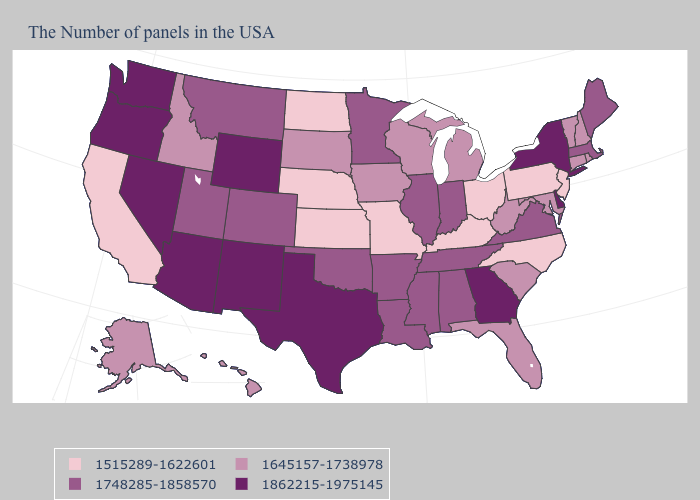Does South Carolina have the lowest value in the USA?
Concise answer only. No. Does Oregon have the highest value in the West?
Quick response, please. Yes. Which states have the lowest value in the Northeast?
Be succinct. New Jersey, Pennsylvania. What is the highest value in the USA?
Be succinct. 1862215-1975145. Does Utah have the lowest value in the USA?
Write a very short answer. No. Name the states that have a value in the range 1862215-1975145?
Be succinct. New York, Delaware, Georgia, Texas, Wyoming, New Mexico, Arizona, Nevada, Washington, Oregon. What is the value of Delaware?
Write a very short answer. 1862215-1975145. Among the states that border Montana , which have the highest value?
Write a very short answer. Wyoming. Among the states that border Pennsylvania , does Maryland have the lowest value?
Answer briefly. No. Name the states that have a value in the range 1515289-1622601?
Keep it brief. New Jersey, Pennsylvania, North Carolina, Ohio, Kentucky, Missouri, Kansas, Nebraska, North Dakota, California. Name the states that have a value in the range 1748285-1858570?
Answer briefly. Maine, Massachusetts, Virginia, Indiana, Alabama, Tennessee, Illinois, Mississippi, Louisiana, Arkansas, Minnesota, Oklahoma, Colorado, Utah, Montana. What is the highest value in the USA?
Write a very short answer. 1862215-1975145. What is the highest value in the MidWest ?
Give a very brief answer. 1748285-1858570. Is the legend a continuous bar?
Quick response, please. No. What is the lowest value in the West?
Quick response, please. 1515289-1622601. 